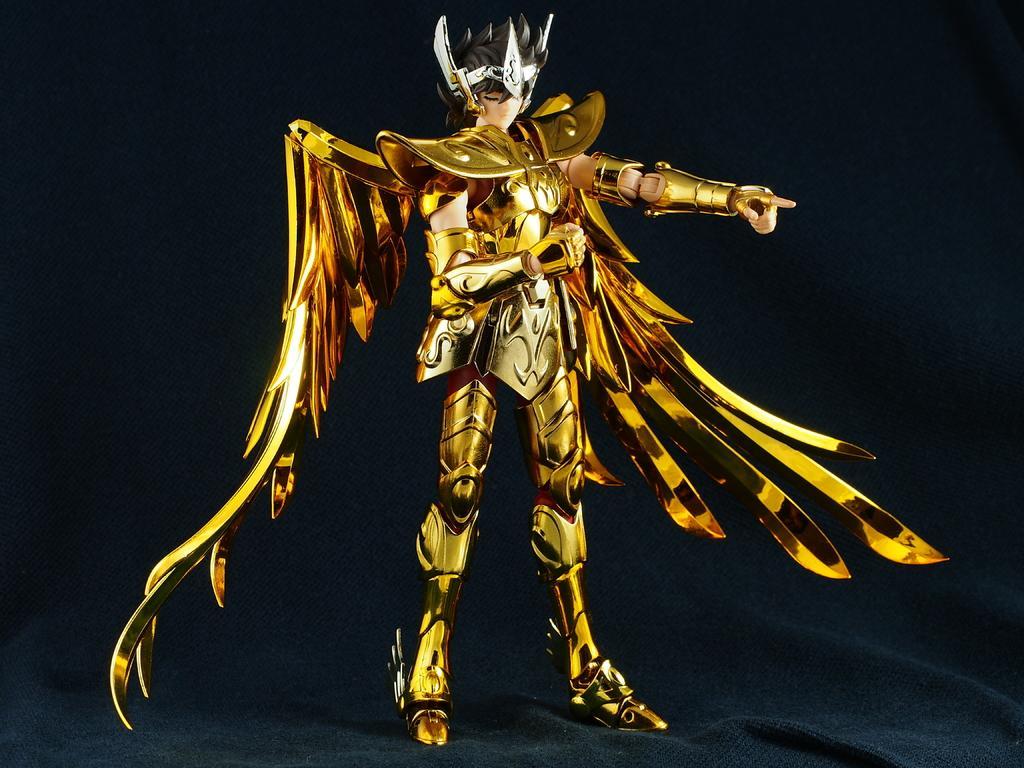Could you give a brief overview of what you see in this image? In this image we can see a cartoon picture of a person, and the background is dark. 